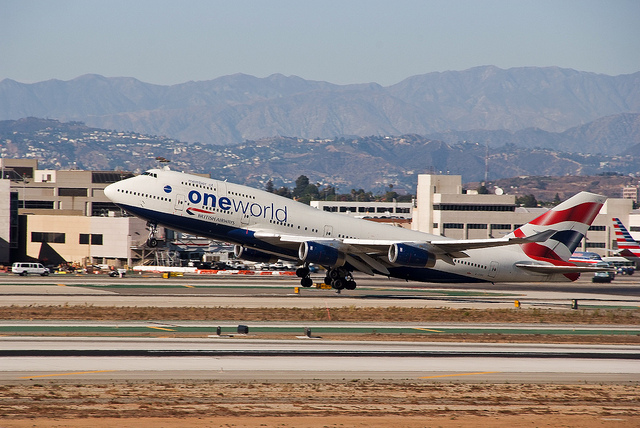What type of aircraft is shown in the picture? The image showcases a commercial airliner, specifically a Boeing 747, recognizable by its distinctive hump at the front of the fuselage, often referred to as the 'Queen of the Skies'. 